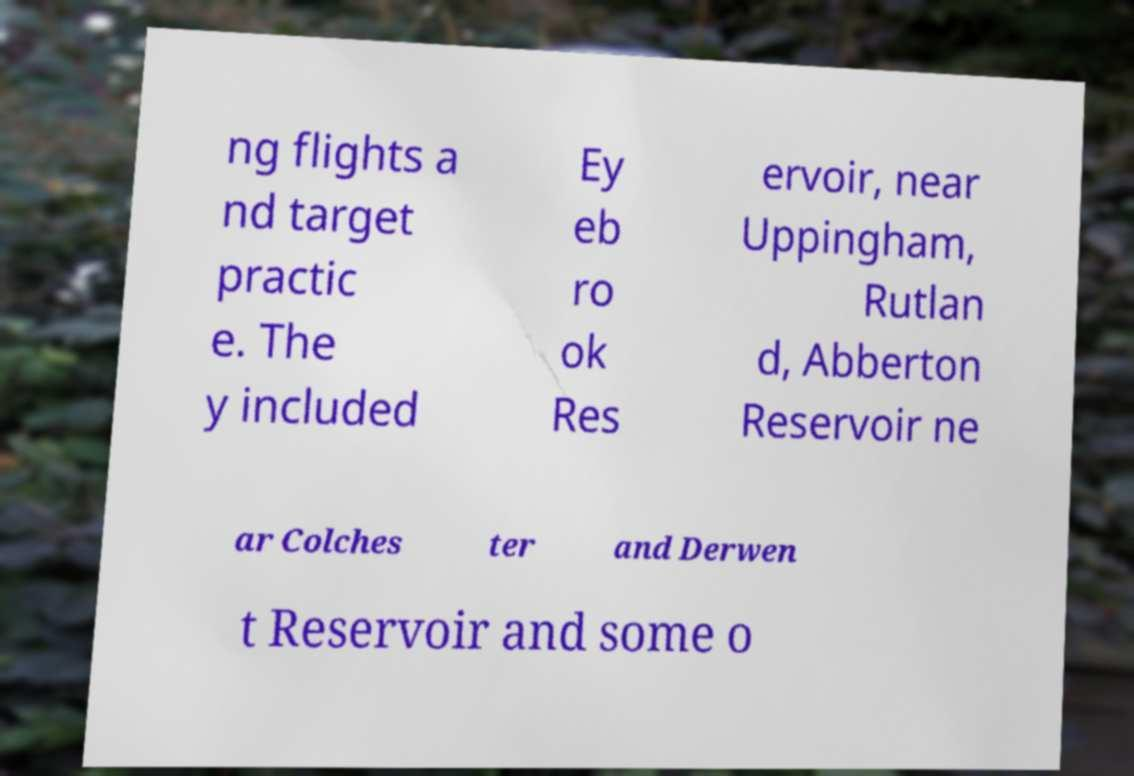What messages or text are displayed in this image? I need them in a readable, typed format. ng flights a nd target practic e. The y included Ey eb ro ok Res ervoir, near Uppingham, Rutlan d, Abberton Reservoir ne ar Colches ter and Derwen t Reservoir and some o 